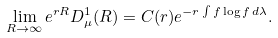<formula> <loc_0><loc_0><loc_500><loc_500>\lim _ { R \rightarrow \infty } e ^ { r R } D _ { \mu } ^ { 1 } ( R ) = C ( r ) e ^ { - r \int f \log f \, d \lambda } .</formula> 